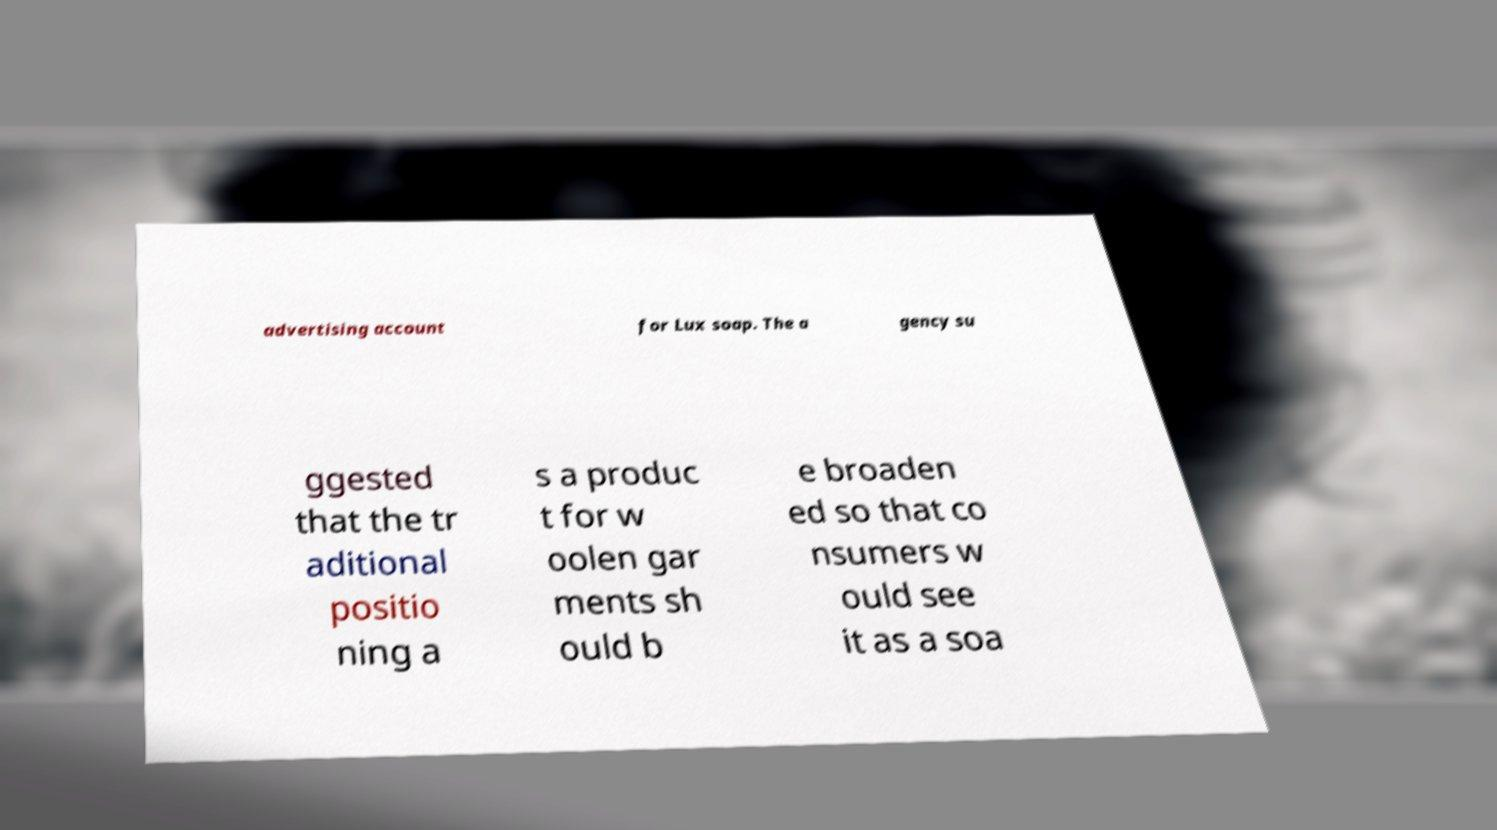Please identify and transcribe the text found in this image. advertising account for Lux soap. The a gency su ggested that the tr aditional positio ning a s a produc t for w oolen gar ments sh ould b e broaden ed so that co nsumers w ould see it as a soa 